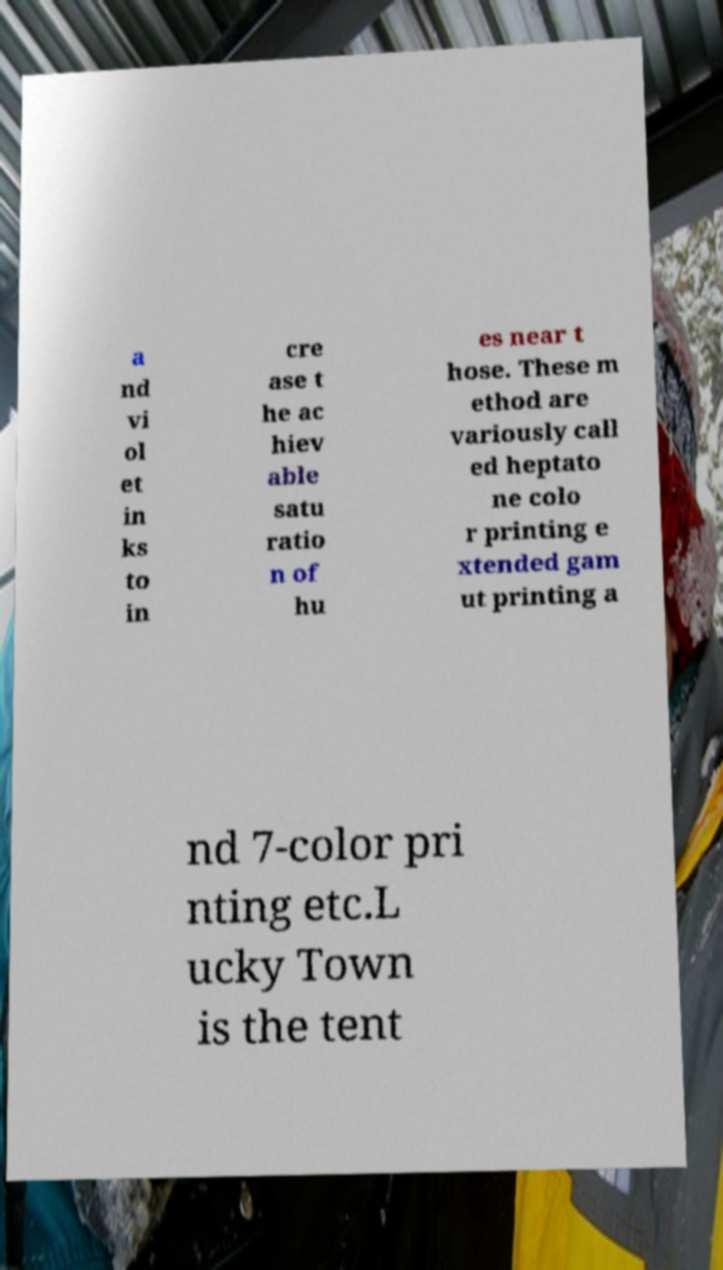For documentation purposes, I need the text within this image transcribed. Could you provide that? a nd vi ol et in ks to in cre ase t he ac hiev able satu ratio n of hu es near t hose. These m ethod are variously call ed heptato ne colo r printing e xtended gam ut printing a nd 7-color pri nting etc.L ucky Town is the tent 